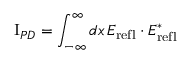Convert formula to latex. <formula><loc_0><loc_0><loc_500><loc_500>I _ { P D } = \int _ { - \infty } ^ { \infty } d x \, E _ { r e f l } \cdot E _ { r e f l } ^ { * }</formula> 